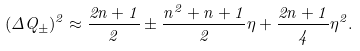Convert formula to latex. <formula><loc_0><loc_0><loc_500><loc_500>( \Delta Q _ { \pm } ) ^ { 2 } \approx \frac { 2 n + 1 } { 2 } \pm \frac { n ^ { 2 } + n + 1 } { 2 } \eta + \frac { 2 n + 1 } { 4 } \eta ^ { 2 } .</formula> 